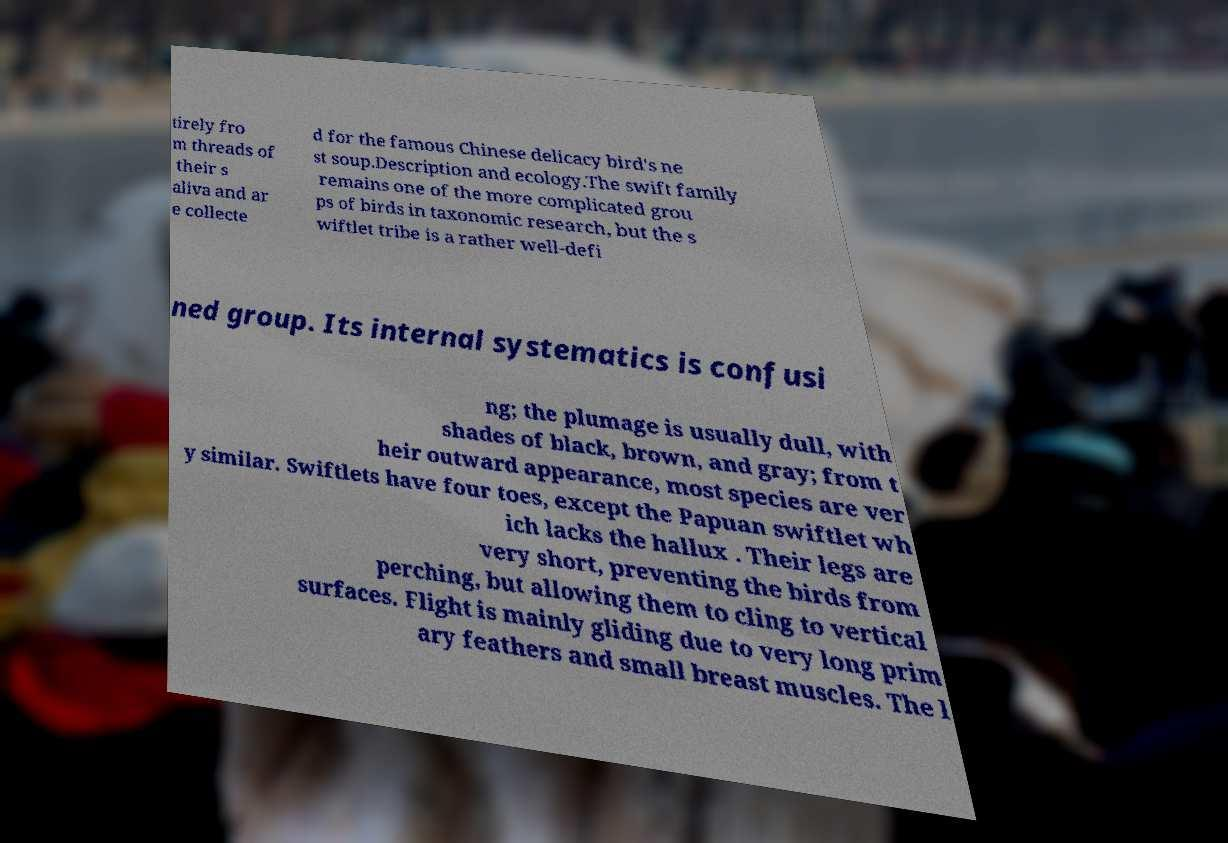There's text embedded in this image that I need extracted. Can you transcribe it verbatim? tirely fro m threads of their s aliva and ar e collecte d for the famous Chinese delicacy bird's ne st soup.Description and ecology.The swift family remains one of the more complicated grou ps of birds in taxonomic research, but the s wiftlet tribe is a rather well-defi ned group. Its internal systematics is confusi ng; the plumage is usually dull, with shades of black, brown, and gray; from t heir outward appearance, most species are ver y similar. Swiftlets have four toes, except the Papuan swiftlet wh ich lacks the hallux . Their legs are very short, preventing the birds from perching, but allowing them to cling to vertical surfaces. Flight is mainly gliding due to very long prim ary feathers and small breast muscles. The l 